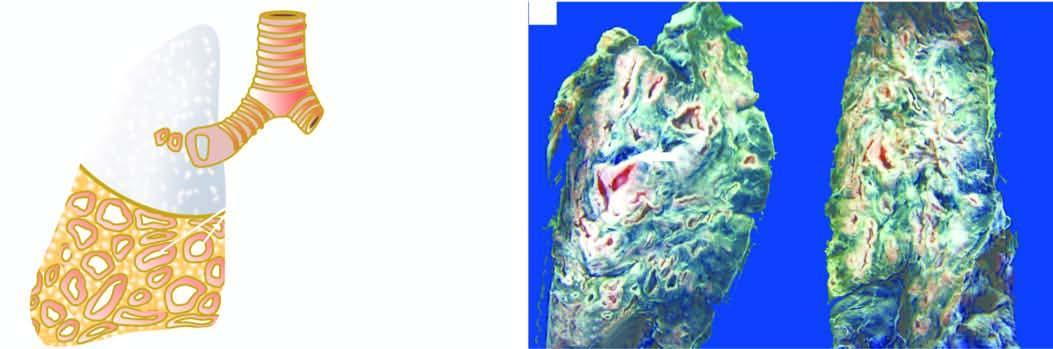s the section of the mitral valve seen?
Answer the question using a single word or phrase. No 